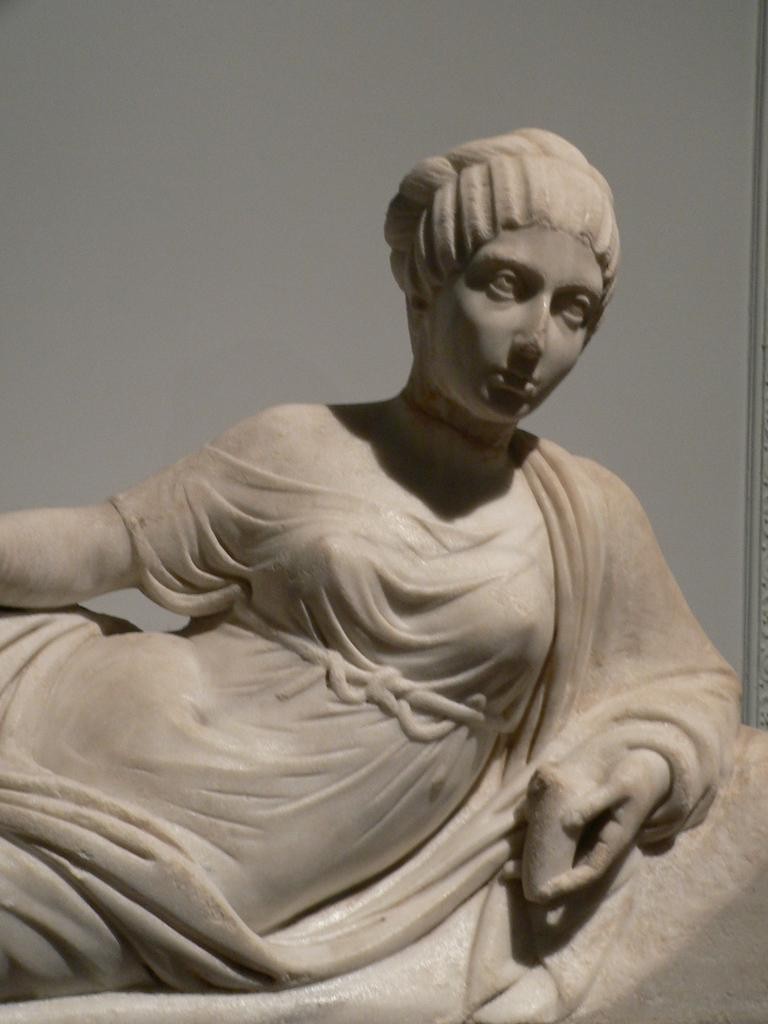Where was the image taken? The image was taken indoors. What can be seen in the background of the image? There is a wall in the background of the image. What is the main subject of the image? There is a sculpture of a woman in the middle of the image. What type of fruit is the woman holding in the image? There is no fruit present in the image; the woman is a sculpture and not holding any fruit. 